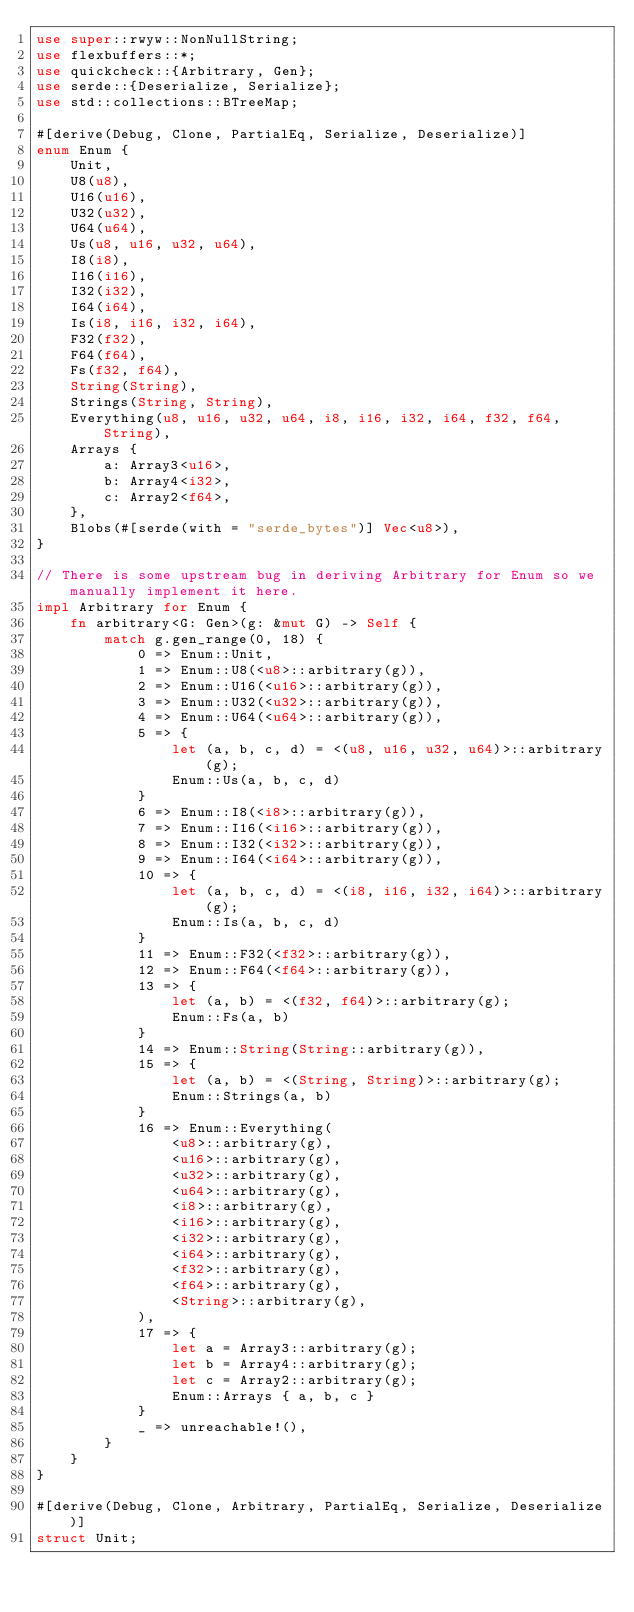Convert code to text. <code><loc_0><loc_0><loc_500><loc_500><_Rust_>use super::rwyw::NonNullString;
use flexbuffers::*;
use quickcheck::{Arbitrary, Gen};
use serde::{Deserialize, Serialize};
use std::collections::BTreeMap;

#[derive(Debug, Clone, PartialEq, Serialize, Deserialize)]
enum Enum {
    Unit,
    U8(u8),
    U16(u16),
    U32(u32),
    U64(u64),
    Us(u8, u16, u32, u64),
    I8(i8),
    I16(i16),
    I32(i32),
    I64(i64),
    Is(i8, i16, i32, i64),
    F32(f32),
    F64(f64),
    Fs(f32, f64),
    String(String),
    Strings(String, String),
    Everything(u8, u16, u32, u64, i8, i16, i32, i64, f32, f64, String),
    Arrays {
        a: Array3<u16>,
        b: Array4<i32>,
        c: Array2<f64>,
    },
    Blobs(#[serde(with = "serde_bytes")] Vec<u8>),
}

// There is some upstream bug in deriving Arbitrary for Enum so we manually implement it here.
impl Arbitrary for Enum {
    fn arbitrary<G: Gen>(g: &mut G) -> Self {
        match g.gen_range(0, 18) {
            0 => Enum::Unit,
            1 => Enum::U8(<u8>::arbitrary(g)),
            2 => Enum::U16(<u16>::arbitrary(g)),
            3 => Enum::U32(<u32>::arbitrary(g)),
            4 => Enum::U64(<u64>::arbitrary(g)),
            5 => {
                let (a, b, c, d) = <(u8, u16, u32, u64)>::arbitrary(g);
                Enum::Us(a, b, c, d)
            }
            6 => Enum::I8(<i8>::arbitrary(g)),
            7 => Enum::I16(<i16>::arbitrary(g)),
            8 => Enum::I32(<i32>::arbitrary(g)),
            9 => Enum::I64(<i64>::arbitrary(g)),
            10 => {
                let (a, b, c, d) = <(i8, i16, i32, i64)>::arbitrary(g);
                Enum::Is(a, b, c, d)
            }
            11 => Enum::F32(<f32>::arbitrary(g)),
            12 => Enum::F64(<f64>::arbitrary(g)),
            13 => {
                let (a, b) = <(f32, f64)>::arbitrary(g);
                Enum::Fs(a, b)
            }
            14 => Enum::String(String::arbitrary(g)),
            15 => {
                let (a, b) = <(String, String)>::arbitrary(g);
                Enum::Strings(a, b)
            }
            16 => Enum::Everything(
                <u8>::arbitrary(g),
                <u16>::arbitrary(g),
                <u32>::arbitrary(g),
                <u64>::arbitrary(g),
                <i8>::arbitrary(g),
                <i16>::arbitrary(g),
                <i32>::arbitrary(g),
                <i64>::arbitrary(g),
                <f32>::arbitrary(g),
                <f64>::arbitrary(g),
                <String>::arbitrary(g),
            ),
            17 => {
                let a = Array3::arbitrary(g);
                let b = Array4::arbitrary(g);
                let c = Array2::arbitrary(g);
                Enum::Arrays { a, b, c }
            }
            _ => unreachable!(),
        }
    }
}

#[derive(Debug, Clone, Arbitrary, PartialEq, Serialize, Deserialize)]
struct Unit;
</code> 